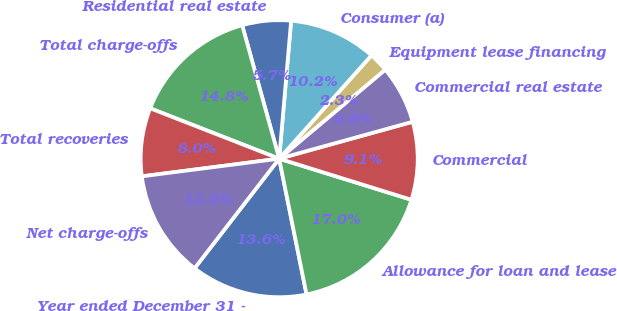Convert chart to OTSL. <chart><loc_0><loc_0><loc_500><loc_500><pie_chart><fcel>Year ended December 31 -<fcel>Allowance for loan and lease<fcel>Commercial<fcel>Commercial real estate<fcel>Equipment lease financing<fcel>Consumer (a)<fcel>Residential real estate<fcel>Total charge-offs<fcel>Total recoveries<fcel>Net charge-offs<nl><fcel>13.63%<fcel>17.04%<fcel>9.09%<fcel>6.82%<fcel>2.28%<fcel>10.23%<fcel>5.68%<fcel>14.77%<fcel>7.96%<fcel>12.5%<nl></chart> 